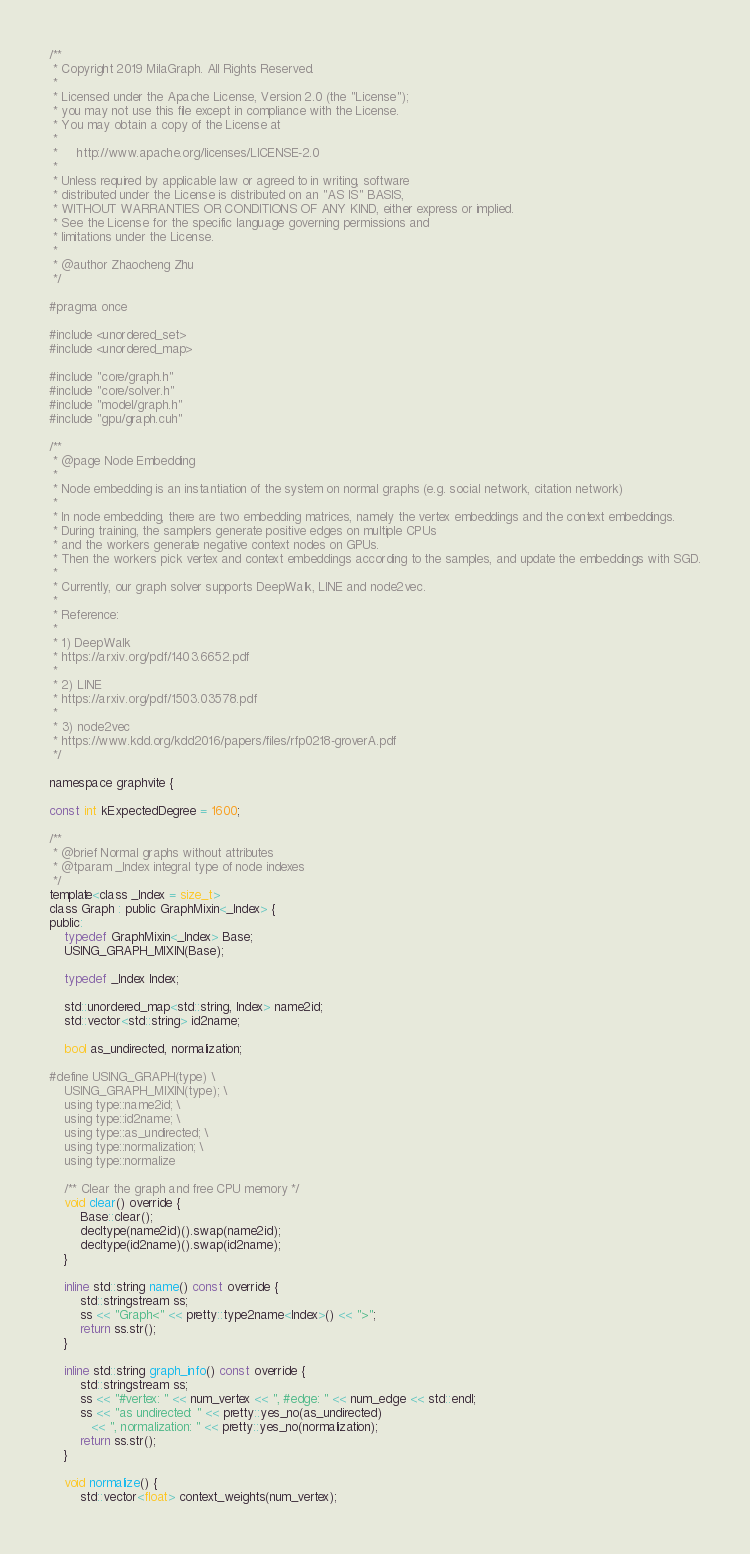<code> <loc_0><loc_0><loc_500><loc_500><_Cuda_>/**
 * Copyright 2019 MilaGraph. All Rights Reserved.
 *
 * Licensed under the Apache License, Version 2.0 (the "License");
 * you may not use this file except in compliance with the License.
 * You may obtain a copy of the License at
 *
 *     http://www.apache.org/licenses/LICENSE-2.0
 *
 * Unless required by applicable law or agreed to in writing, software
 * distributed under the License is distributed on an "AS IS" BASIS,
 * WITHOUT WARRANTIES OR CONDITIONS OF ANY KIND, either express or implied.
 * See the License for the specific language governing permissions and
 * limitations under the License.
 *
 * @author Zhaocheng Zhu
 */

#pragma once

#include <unordered_set>
#include <unordered_map>

#include "core/graph.h"
#include "core/solver.h"
#include "model/graph.h"
#include "gpu/graph.cuh"

/**
 * @page Node Embedding
 *
 * Node embedding is an instantiation of the system on normal graphs (e.g. social network, citation network)
 *
 * In node embedding, there are two embedding matrices, namely the vertex embeddings and the context embeddings.
 * During training, the samplers generate positive edges on multiple CPUs
 * and the workers generate negative context nodes on GPUs.
 * Then the workers pick vertex and context embeddings according to the samples, and update the embeddings with SGD.
 *
 * Currently, our graph solver supports DeepWalk, LINE and node2vec.
 *
 * Reference:
 *
 * 1) DeepWalk
 * https://arxiv.org/pdf/1403.6652.pdf
 *
 * 2) LINE
 * https://arxiv.org/pdf/1503.03578.pdf
 *
 * 3) node2vec
 * https://www.kdd.org/kdd2016/papers/files/rfp0218-groverA.pdf
 */

namespace graphvite {

const int kExpectedDegree = 1600;

/**
 * @brief Normal graphs without attributes
 * @tparam _Index integral type of node indexes
 */
template<class _Index = size_t>
class Graph : public GraphMixin<_Index> {
public:
    typedef GraphMixin<_Index> Base;
    USING_GRAPH_MIXIN(Base);

    typedef _Index Index;

    std::unordered_map<std::string, Index> name2id;
    std::vector<std::string> id2name;

    bool as_undirected, normalization;

#define USING_GRAPH(type) \
    USING_GRAPH_MIXIN(type); \
    using type::name2id; \
    using type::id2name; \
    using type::as_undirected; \
    using type::normalization; \
    using type::normalize

    /** Clear the graph and free CPU memory */
    void clear() override {
        Base::clear();
        decltype(name2id)().swap(name2id);
        decltype(id2name)().swap(id2name);
    }

    inline std::string name() const override {
        std::stringstream ss;
        ss << "Graph<" << pretty::type2name<Index>() << ">";
        return ss.str();
    }

    inline std::string graph_info() const override {
        std::stringstream ss;
        ss << "#vertex: " << num_vertex << ", #edge: " << num_edge << std::endl;
        ss << "as undirected: " << pretty::yes_no(as_undirected)
           << ", normalization: " << pretty::yes_no(normalization);
        return ss.str();
    }

    void normalize() {
        std::vector<float> context_weights(num_vertex);</code> 